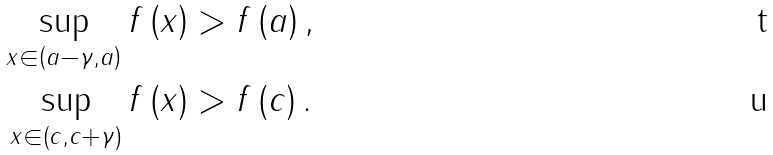Convert formula to latex. <formula><loc_0><loc_0><loc_500><loc_500>\sup _ { x \in \left ( a - \gamma , a \right ) } f \left ( x \right ) & > f \left ( a \right ) , \\ \sup _ { x \in \left ( c , c + \gamma \right ) } f \left ( x \right ) & > f \left ( c \right ) .</formula> 